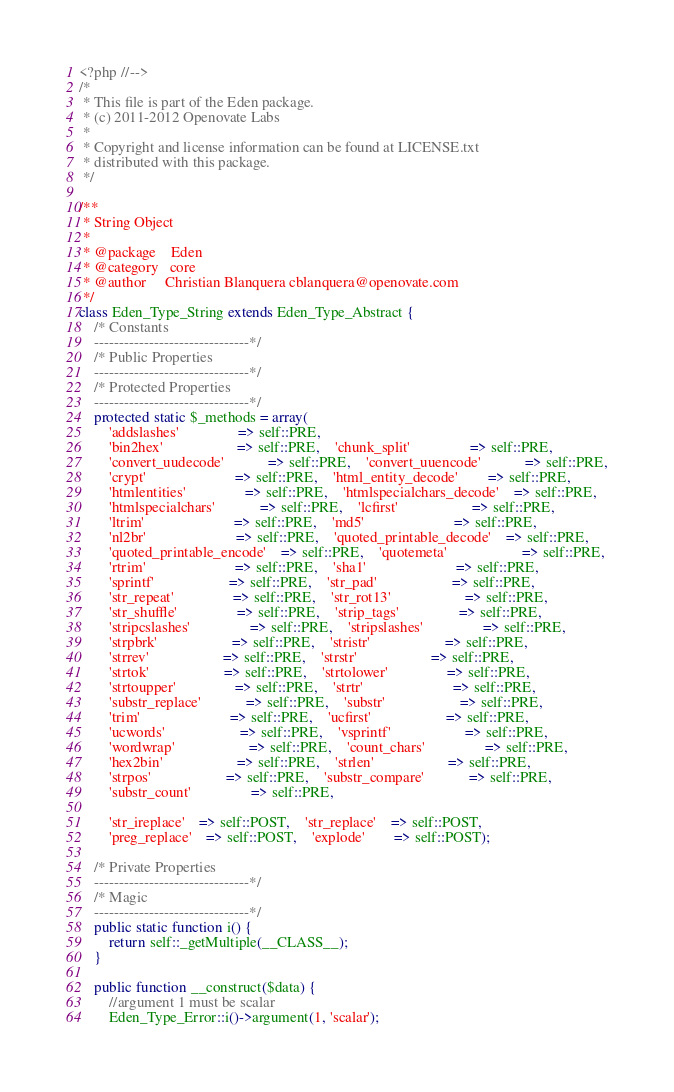<code> <loc_0><loc_0><loc_500><loc_500><_PHP_><?php //-->
/*
 * This file is part of the Eden package.
 * (c) 2011-2012 Openovate Labs
 *
 * Copyright and license information can be found at LICENSE.txt
 * distributed with this package.
 */

/**
 * String Object
 *
 * @package    Eden
 * @category   core
 * @author     Christian Blanquera cblanquera@openovate.com
 */
class Eden_Type_String extends Eden_Type_Abstract {
	/* Constants
	-------------------------------*/
	/* Public Properties
	-------------------------------*/
	/* Protected Properties
	-------------------------------*/
	protected static $_methods = array(
		'addslashes'				=> self::PRE,				
		'bin2hex'					=> self::PRE,	'chunk_split'				=> self::PRE,
		'convert_uudecode'			=> self::PRE,	'convert_uuencode'			=> self::PRE,
		'crypt'						=> self::PRE,	'html_entity_decode'		=> self::PRE,
		'htmlentities'				=> self::PRE,	'htmlspecialchars_decode'	=> self::PRE,
		'htmlspecialchars'			=> self::PRE,	'lcfirst'					=> self::PRE,
		'ltrim'						=> self::PRE,	'md5'						=> self::PRE,
		'nl2br'						=> self::PRE,	'quoted_printable_decode'	=> self::PRE,
		'quoted_printable_encode'	=> self::PRE,	'quotemeta'					=> self::PRE,
		'rtrim'						=> self::PRE,	'sha1'						=> self::PRE,
		'sprintf'					=> self::PRE,	'str_pad'					=> self::PRE,
		'str_repeat'				=> self::PRE,	'str_rot13'					=> self::PRE,
		'str_shuffle'				=> self::PRE,	'strip_tags'				=> self::PRE,
		'stripcslashes'				=> self::PRE,	'stripslashes'				=> self::PRE,
		'strpbrk'					=> self::PRE,	'stristr'					=> self::PRE,
		'strrev'					=> self::PRE,	'strstr'					=> self::PRE,
		'strtok'					=> self::PRE,	'strtolower'				=> self::PRE,
		'strtoupper'				=> self::PRE,	'strtr'						=> self::PRE,
		'substr_replace'			=> self::PRE,	'substr'					=> self::PRE,
		'trim'						=> self::PRE,	'ucfirst'					=> self::PRE,
		'ucwords'					=> self::PRE,	'vsprintf'					=> self::PRE,
		'wordwrap'					=> self::PRE,	'count_chars'				=> self::PRE,
		'hex2bin'					=> self::PRE,	'strlen'					=> self::PRE,
		'strpos'					=> self::PRE,	'substr_compare'			=> self::PRE,
		'substr_count'				=> self::PRE,	
		
		'str_ireplace'	=> self::POST,	'str_replace'	=> self::POST, 
		'preg_replace'	=> self::POST, 	'explode'		=> self::POST);
	
	/* Private Properties
	-------------------------------*/
	/* Magic
	-------------------------------*/
	public static function i() {
		return self::_getMultiple(__CLASS__);
	}
	
	public function __construct($data) {
		//argument 1 must be scalar
		Eden_Type_Error::i()->argument(1, 'scalar');</code> 